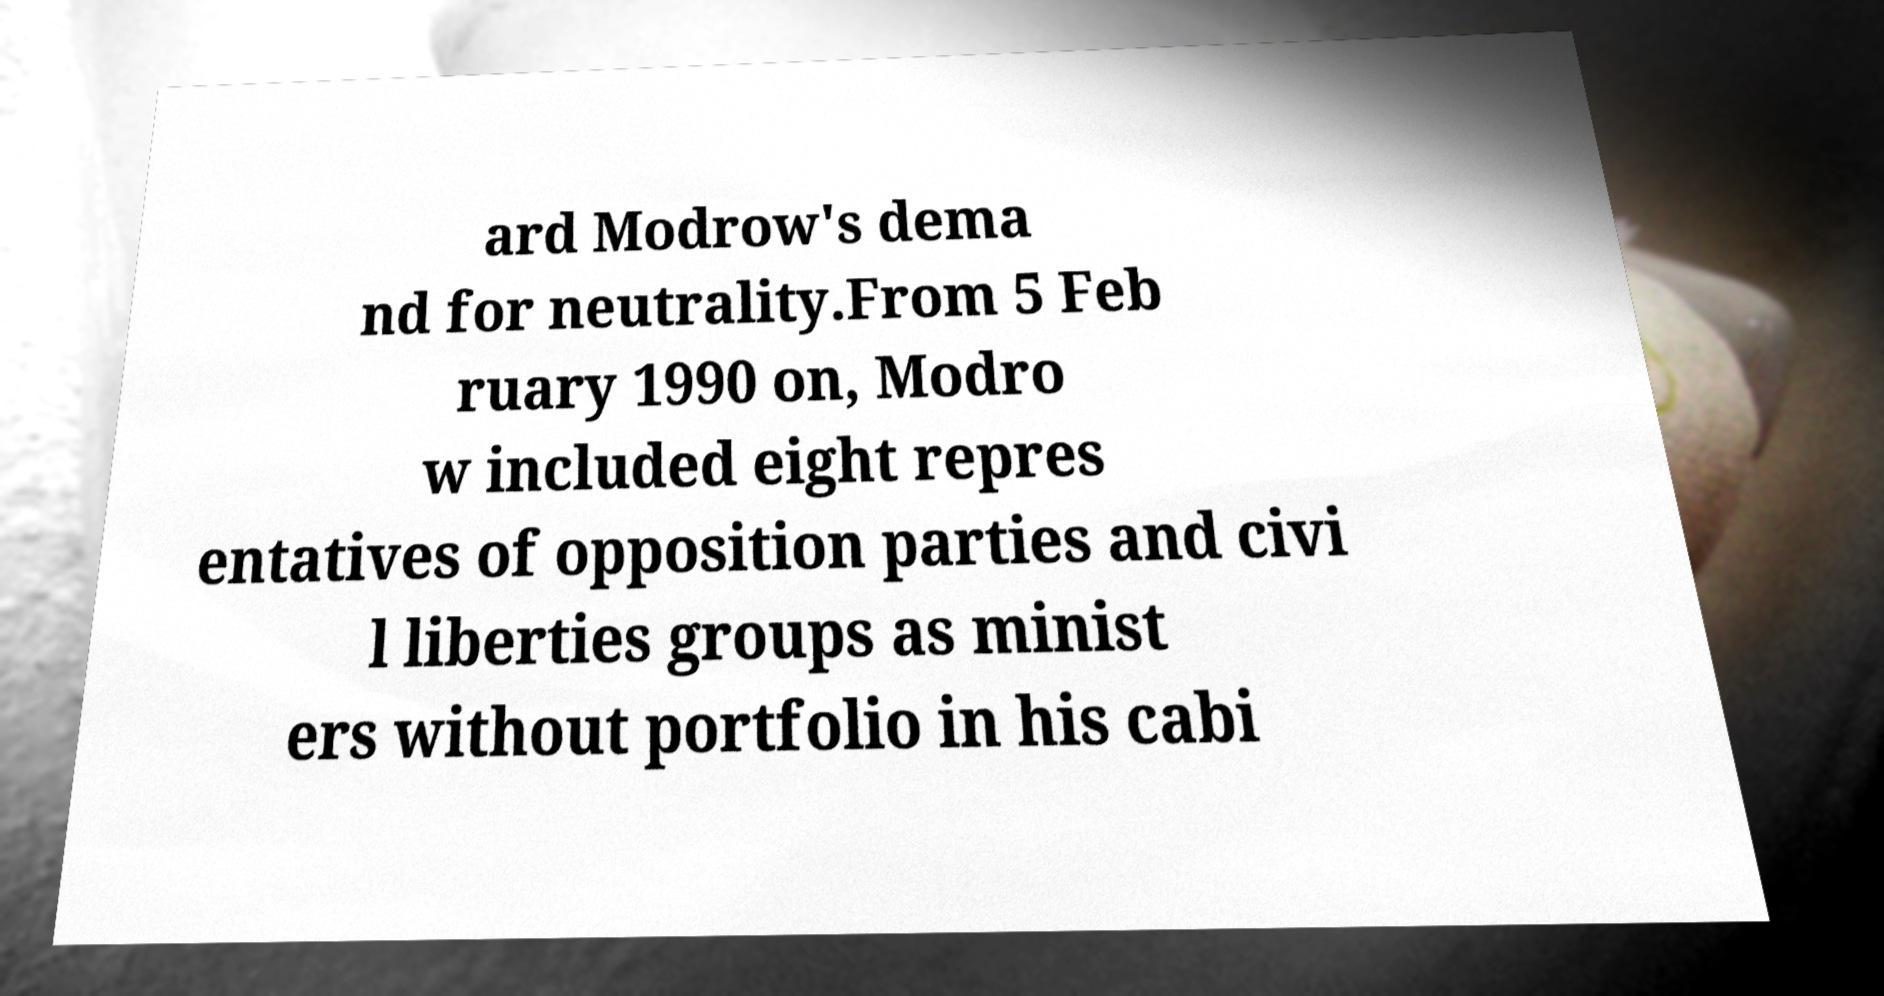Can you read and provide the text displayed in the image?This photo seems to have some interesting text. Can you extract and type it out for me? ard Modrow's dema nd for neutrality.From 5 Feb ruary 1990 on, Modro w included eight repres entatives of opposition parties and civi l liberties groups as minist ers without portfolio in his cabi 